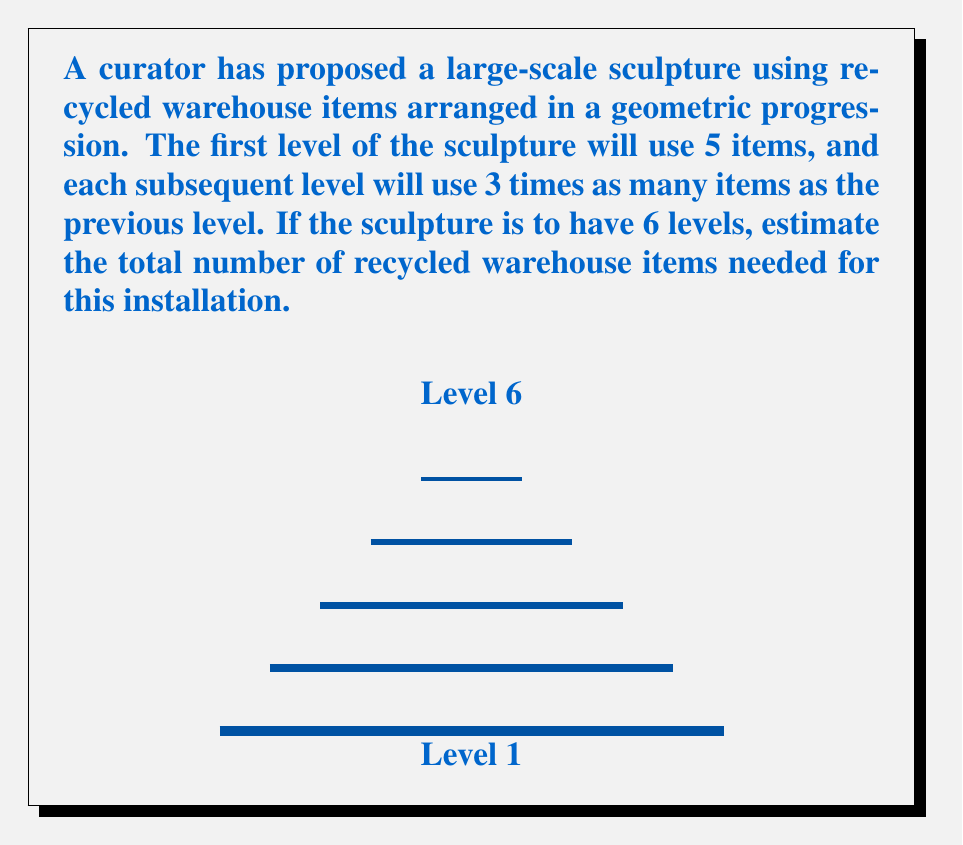Can you solve this math problem? To solve this problem, we'll use the formula for the sum of a geometric progression:

$$S_n = a\frac{1-r^n}{1-r}$$

Where:
$S_n$ is the sum of the series
$a$ is the first term
$r$ is the common ratio
$n$ is the number of terms

Given:
- First level uses 5 items: $a = 5$
- Each level uses 3 times as many as the previous: $r = 3$
- There are 6 levels: $n = 6$

Step 1: Substitute the values into the formula:
$$S_6 = 5\frac{1-3^6}{1-3}$$

Step 2: Calculate $3^6$:
$$3^6 = 729$$

Step 3: Substitute this value:
$$S_6 = 5\frac{1-729}{1-3} = 5\frac{-728}{-2}$$

Step 4: Simplify:
$$S_6 = 5 \times 364 = 1820$$

Therefore, the estimated total number of recycled warehouse items needed for the sculpture is 1,820.
Answer: 1,820 items 